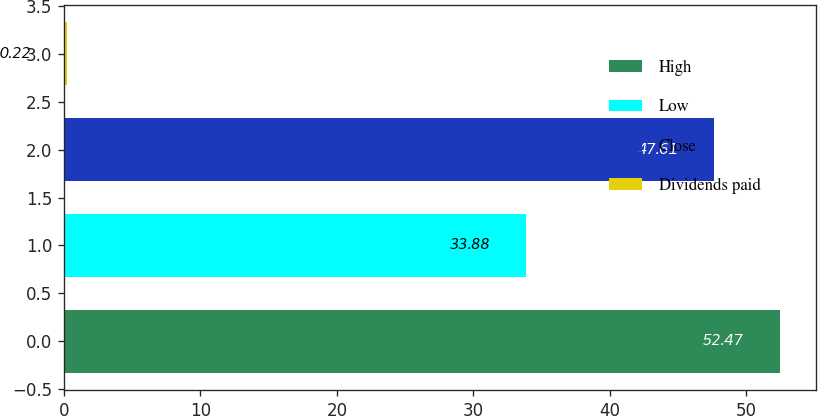<chart> <loc_0><loc_0><loc_500><loc_500><bar_chart><fcel>High<fcel>Low<fcel>Close<fcel>Dividends paid<nl><fcel>52.47<fcel>33.88<fcel>47.61<fcel>0.22<nl></chart> 